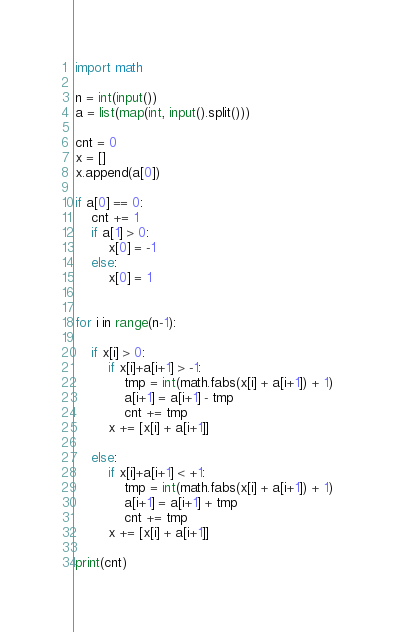<code> <loc_0><loc_0><loc_500><loc_500><_Python_>import math

n = int(input())
a = list(map(int, input().split()))

cnt = 0
x = []
x.append(a[0])

if a[0] == 0:
    cnt += 1
    if a[1] > 0:
        x[0] = -1
    else:
        x[0] = 1


for i in range(n-1):
    
    if x[i] > 0:
        if x[i]+a[i+1] > -1:
            tmp = int(math.fabs(x[i] + a[i+1]) + 1)
            a[i+1] = a[i+1] - tmp
            cnt += tmp
        x += [x[i] + a[i+1]]
        
    else:
        if x[i]+a[i+1] < +1:
            tmp = int(math.fabs(x[i] + a[i+1]) + 1)
            a[i+1] = a[i+1] + tmp
            cnt += tmp
        x += [x[i] + a[i+1]]

print(cnt)</code> 